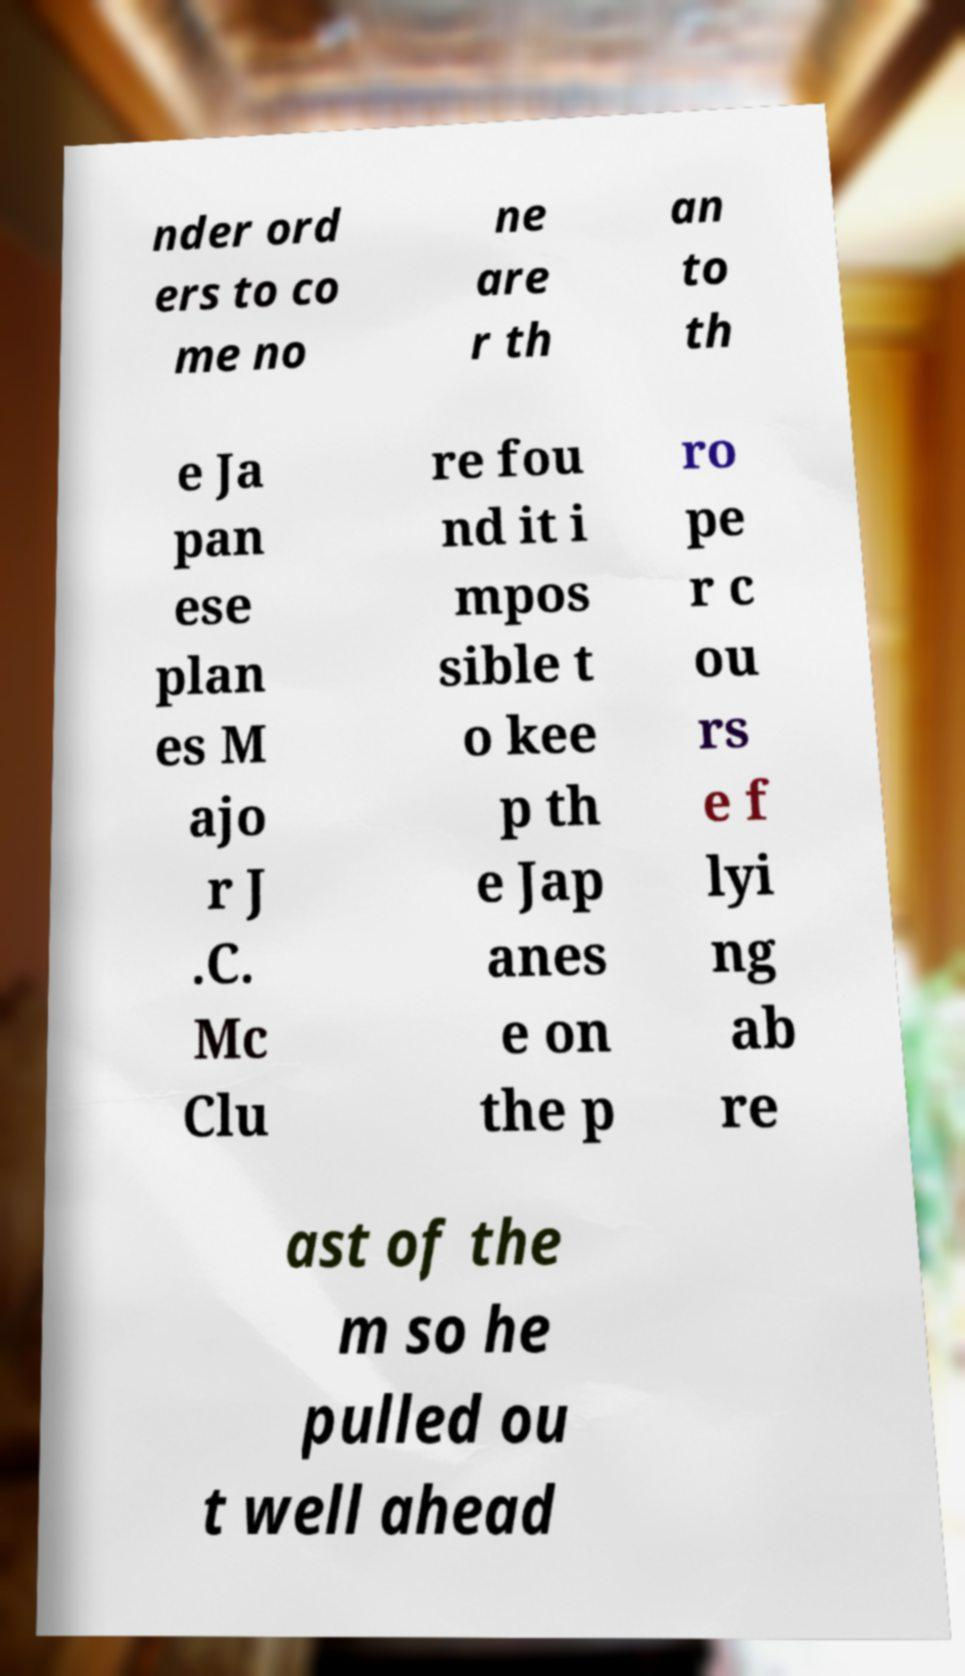Can you accurately transcribe the text from the provided image for me? nder ord ers to co me no ne are r th an to th e Ja pan ese plan es M ajo r J .C. Mc Clu re fou nd it i mpos sible t o kee p th e Jap anes e on the p ro pe r c ou rs e f lyi ng ab re ast of the m so he pulled ou t well ahead 